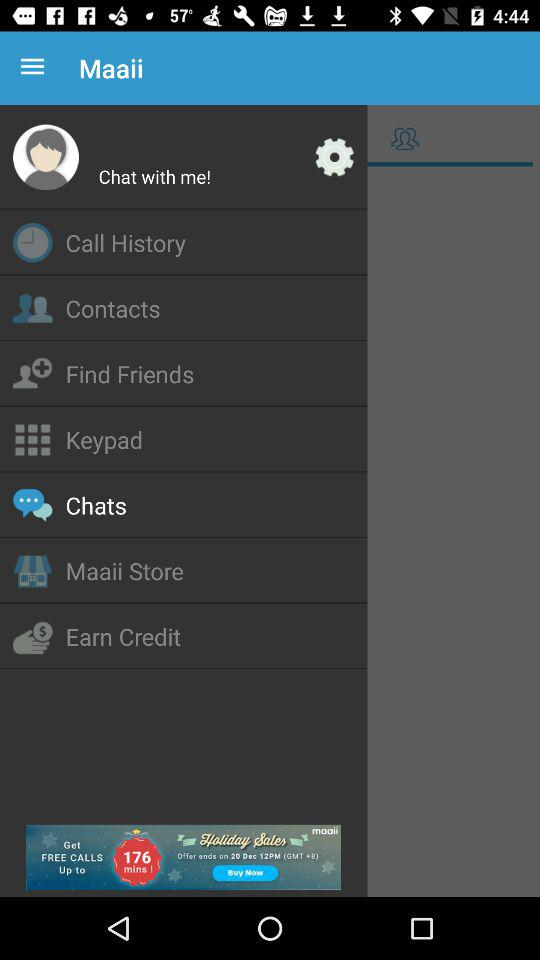How many notifications are there in "Chats"?
When the provided information is insufficient, respond with <no answer>. <no answer> 